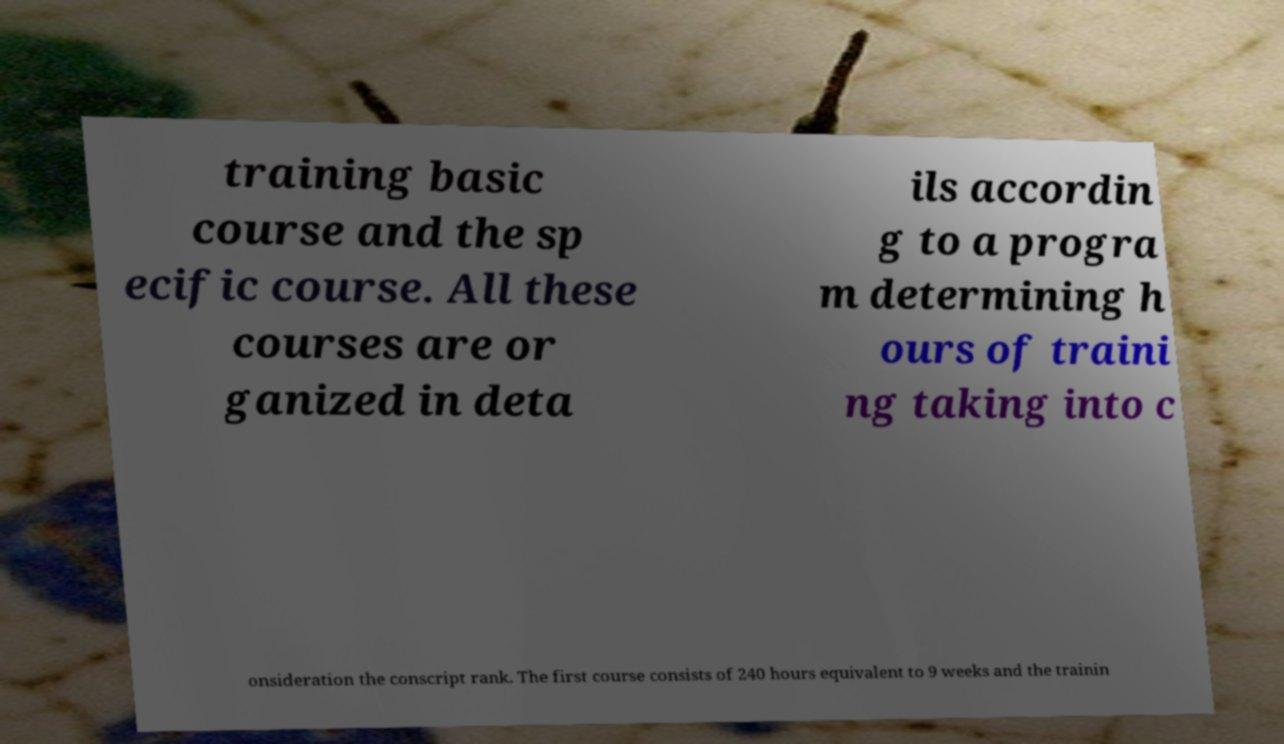For documentation purposes, I need the text within this image transcribed. Could you provide that? training basic course and the sp ecific course. All these courses are or ganized in deta ils accordin g to a progra m determining h ours of traini ng taking into c onsideration the conscript rank. The first course consists of 240 hours equivalent to 9 weeks and the trainin 